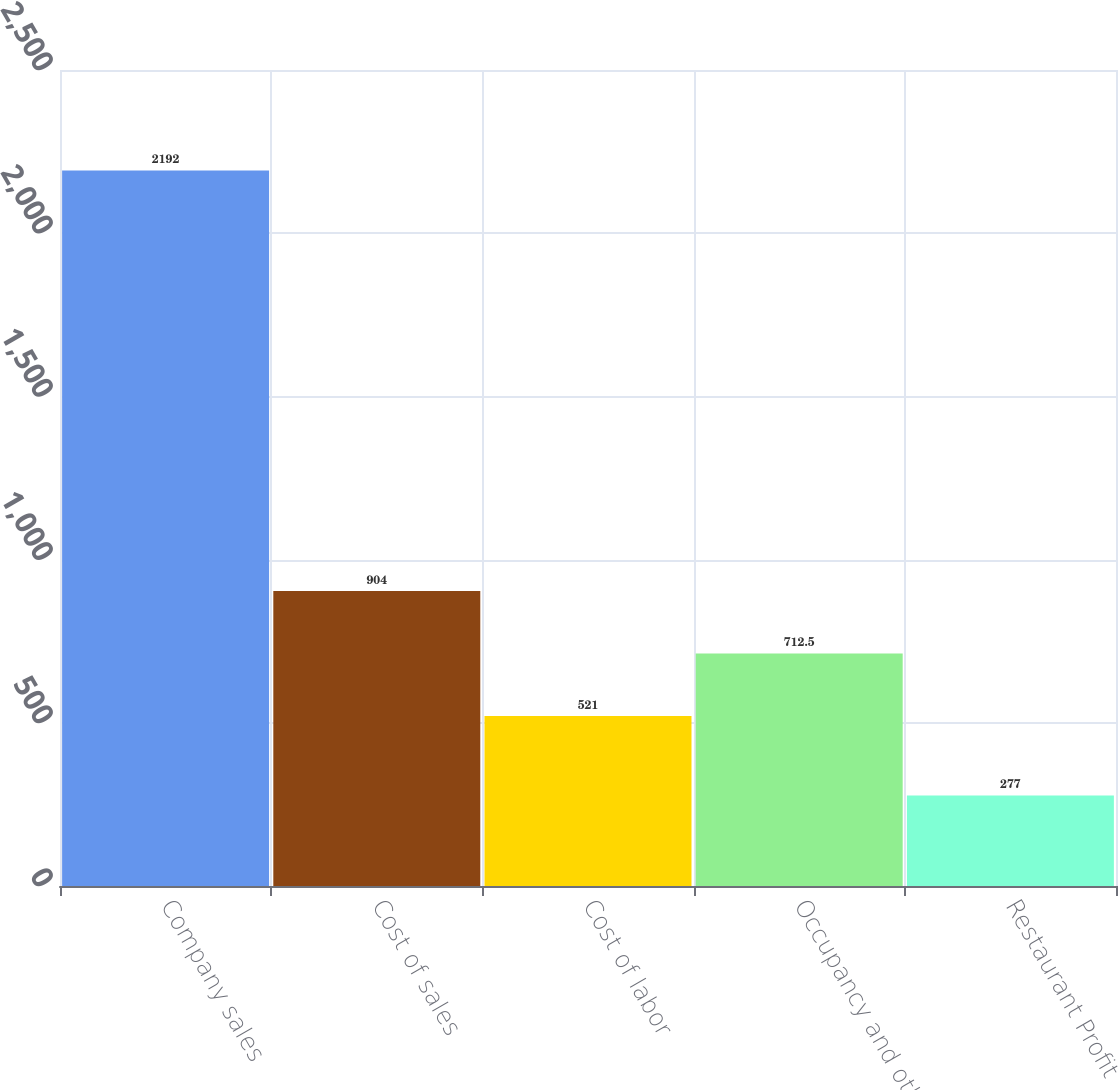<chart> <loc_0><loc_0><loc_500><loc_500><bar_chart><fcel>Company sales<fcel>Cost of sales<fcel>Cost of labor<fcel>Occupancy and other<fcel>Restaurant Profit<nl><fcel>2192<fcel>904<fcel>521<fcel>712.5<fcel>277<nl></chart> 